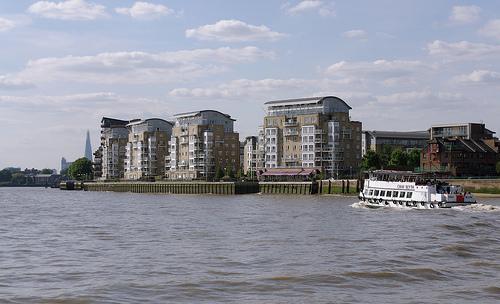How many boats?
Give a very brief answer. 1. 